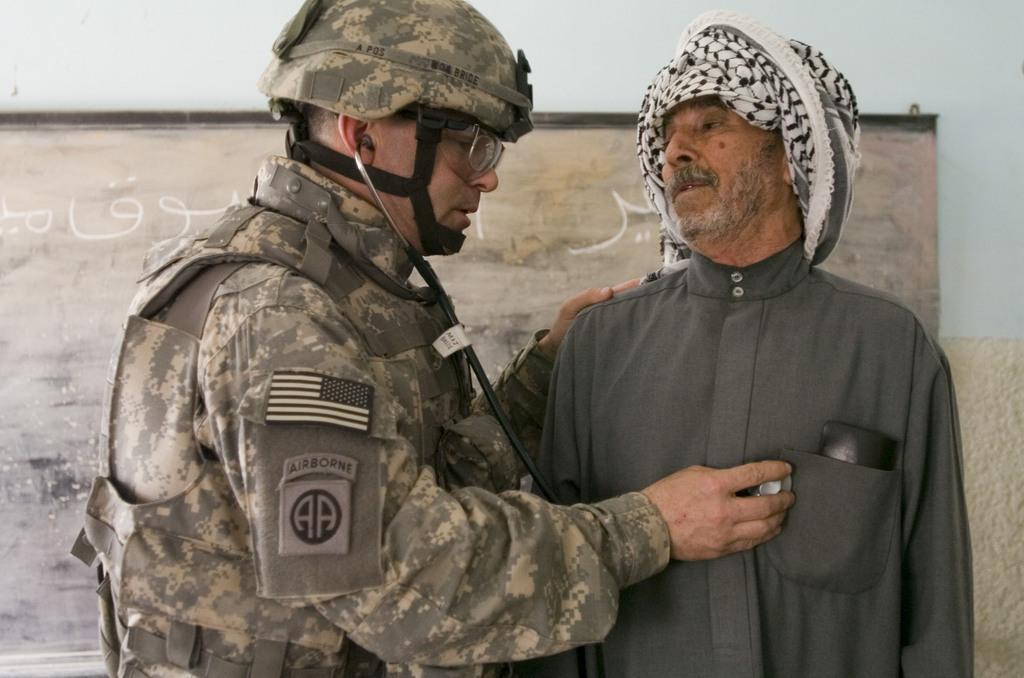Can you describe this image briefly? In this image we can see two persons, a person is holding a stethoscope and there is a board to the wall in the background. 